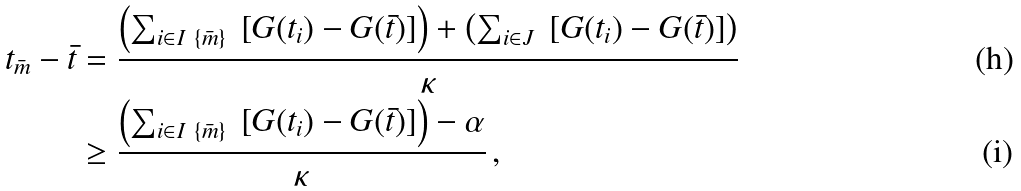Convert formula to latex. <formula><loc_0><loc_0><loc_500><loc_500>t _ { \bar { m } } - \bar { t } & = \frac { \left ( \sum _ { i \in I \ \{ { \bar { m } } \} } \ \left [ G ( t _ { i } ) - G ( \bar { t } ) \right ] \right ) + \left ( \sum _ { i \in J } \ \left [ G ( t _ { i } ) - G ( \bar { t } ) \right ] \right ) } { \kappa } \\ & \geq \frac { \left ( \sum _ { i \in I \ \{ { \bar { m } } \} } \ \left [ G ( t _ { i } ) - G ( \bar { t } ) \right ] \right ) - \alpha } { \kappa } \, ,</formula> 